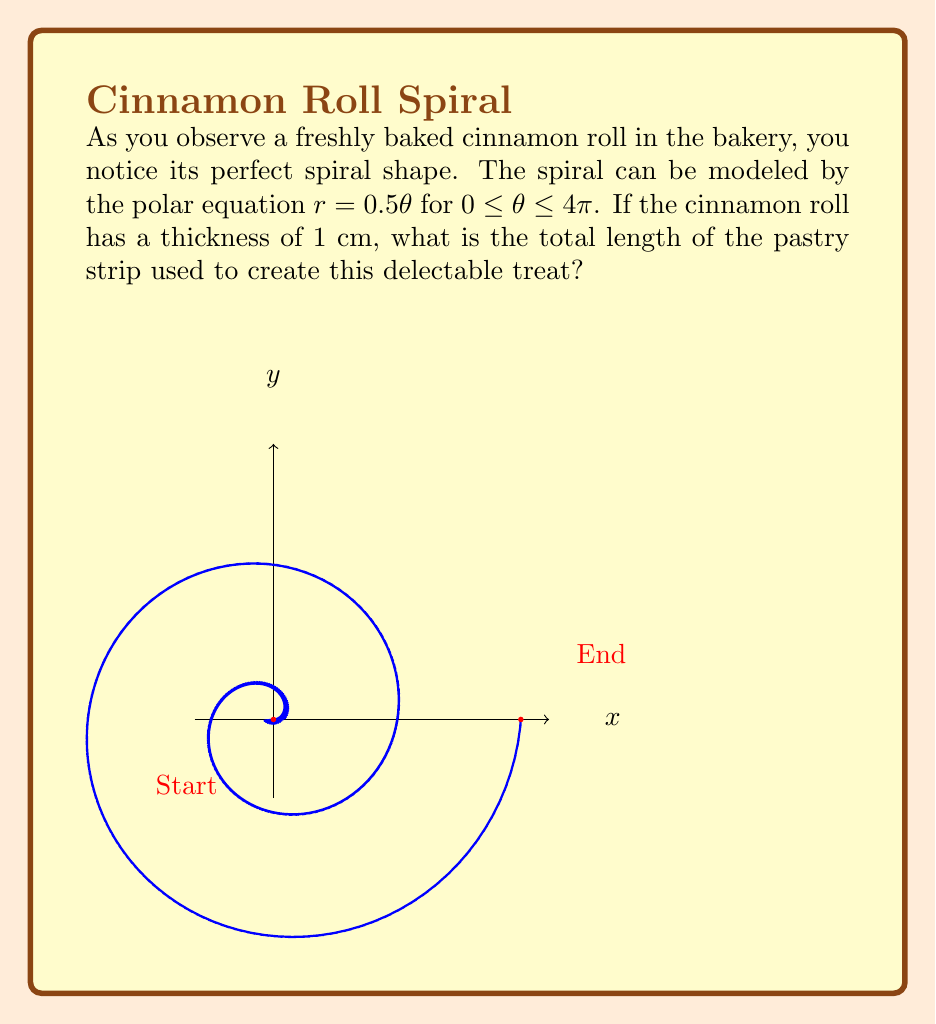What is the answer to this math problem? Let's approach this step-by-step:

1) The length of a curve in polar coordinates is given by the formula:

   $$L = \int_a^b \sqrt{r^2 + \left(\frac{dr}{d\theta}\right)^2} d\theta$$

2) We're given $r = 0.5\theta$, so $\frac{dr}{d\theta} = 0.5$

3) Substituting these into our formula:

   $$L = \int_0^{4\pi} \sqrt{(0.5\theta)^2 + (0.5)^2} d\theta$$

4) Simplifying under the square root:

   $$L = \int_0^{4\pi} \sqrt{0.25\theta^2 + 0.25} d\theta = \frac{1}{2}\int_0^{4\pi} \sqrt{\theta^2 + 1} d\theta$$

5) This integral can be solved using the substitution $\theta = \sinh u$:

   $$L = \frac{1}{2}[\theta\sqrt{\theta^2+1} + \ln(\theta + \sqrt{\theta^2+1})]_0^{4\pi}$$

6) Evaluating at the limits:

   $$L = \frac{1}{2}[4\pi\sqrt{16\pi^2+1} + \ln(4\pi + \sqrt{16\pi^2+1}) - 0 - 0]$$

7) This gives us the length of the spiral. To get the total length of the pastry strip, we need to add the thickness of the roll for each complete revolution. There are two complete revolutions (as $\theta$ goes from 0 to $4\pi$), so we add $2\pi$ cm to our result.

8) Therefore, the total length is:

   $$L_{total} = \frac{1}{2}[4\pi\sqrt{16\pi^2+1} + \ln(4\pi + \sqrt{16\pi^2+1})] + 2\pi$$
Answer: $\frac{1}{2}[4\pi\sqrt{16\pi^2+1} + \ln(4\pi + \sqrt{16\pi^2+1})] + 2\pi$ cm 